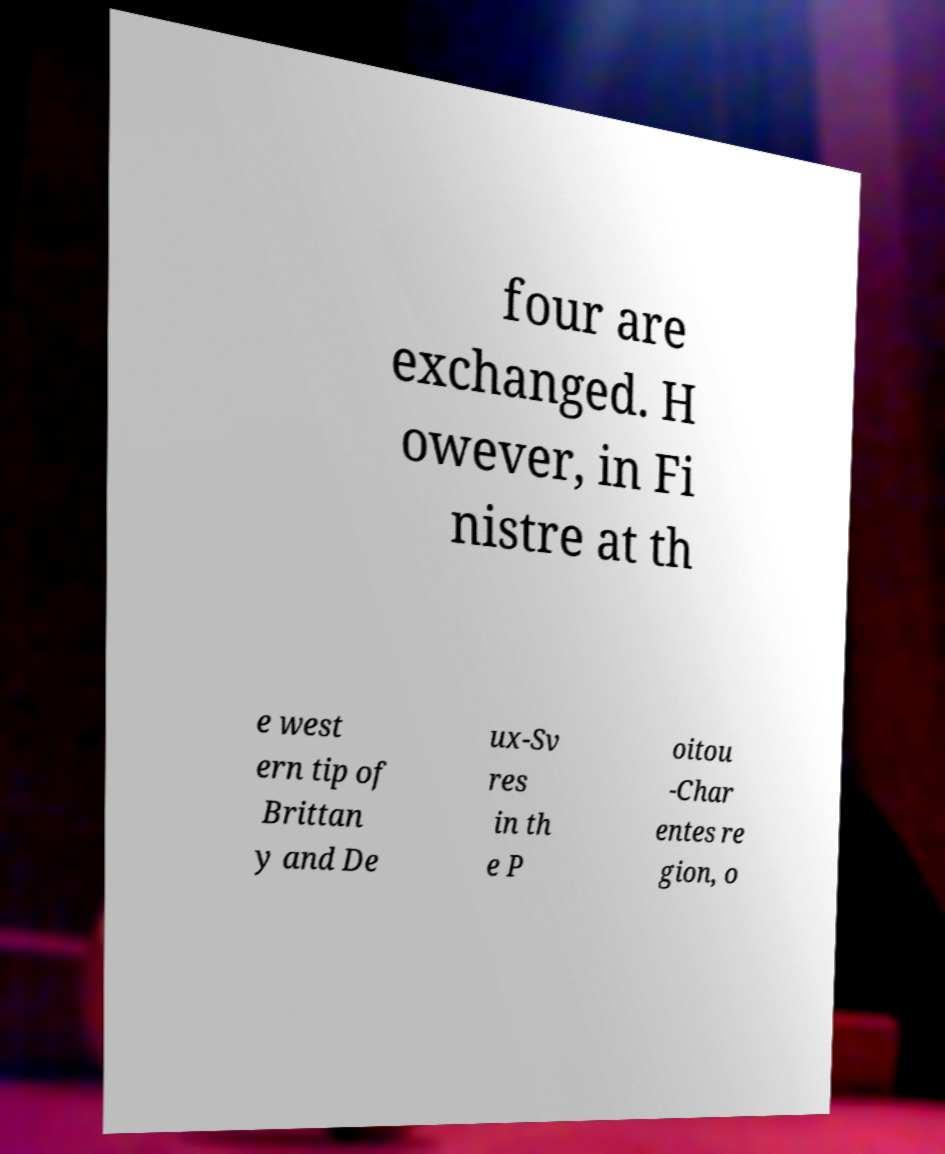Please identify and transcribe the text found in this image. four are exchanged. H owever, in Fi nistre at th e west ern tip of Brittan y and De ux-Sv res in th e P oitou -Char entes re gion, o 